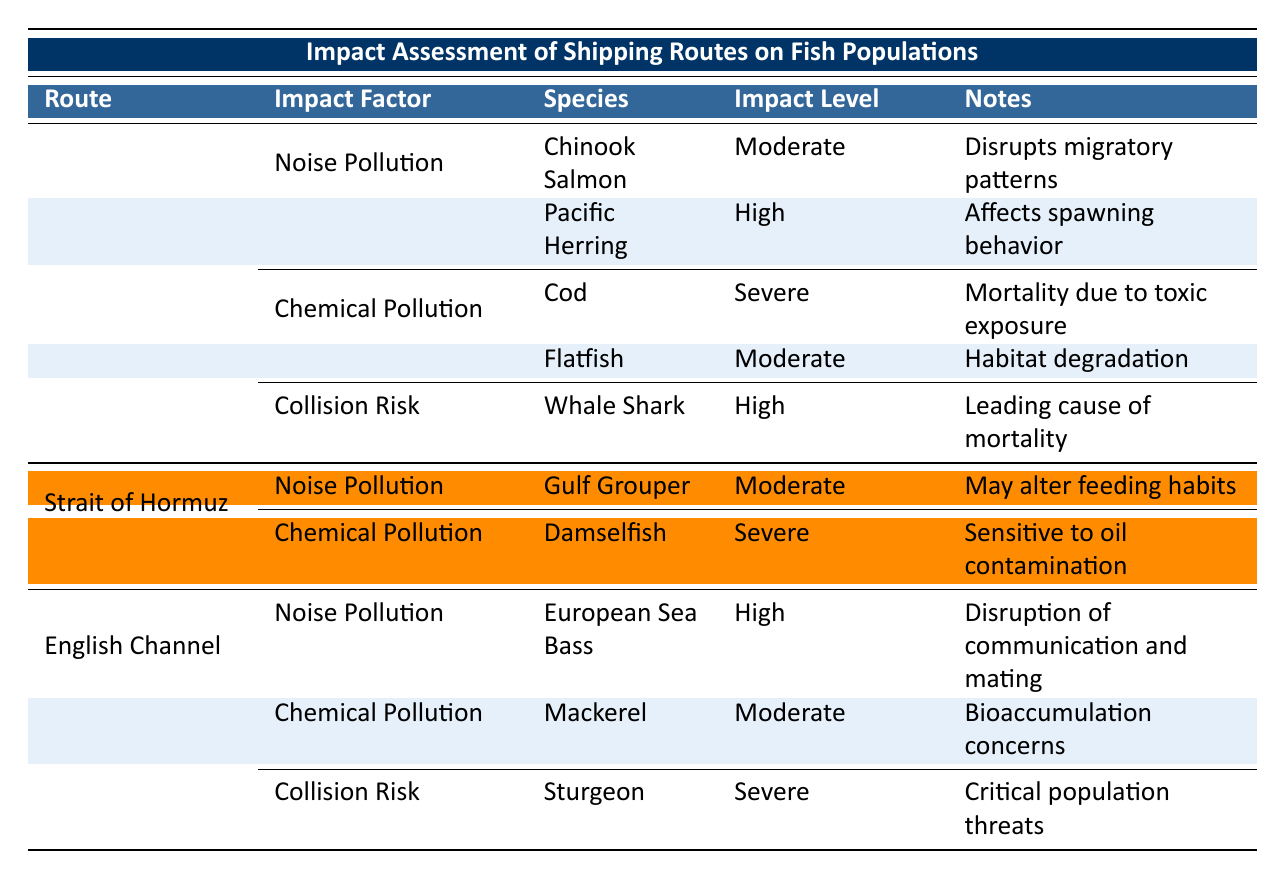What are the impact factors listed for the Bering Sea Route? The table lists Noise Pollution, Chemical Pollution, and Collision Risk as the impact factors for the Bering Sea Route. This is directly observed from the corresponding rows under the route name.
Answer: Noise Pollution, Chemical Pollution, Collision Risk Which fish species are severely impacted by chemical pollution in the Bering Sea Route? The only species listed under severe impact for chemical pollution in the Bering Sea Route is Cod; this can be identified by filtering for the Bering Sea Route and checking the impact level under Chemical Pollution.
Answer: Cod Is the impact level for Pacific Herring higher than that for Flatfish in the Bering Sea Route? Yes, the impact level for Pacific Herring is high while for Flatfish it is moderate. This comparison can be made by looking at the respective impact levels listed for these species in the Bering Sea Route.
Answer: Yes Which shipping route has a fish species that is severely affected by both noise and chemical pollution? The English Channel has Sturgeon, which is severely impacted by collision risk, but none in the table is indicated to be severely affected by both noise and chemical pollution. Therefore, the answer is that no such route exists.
Answer: No What is the total number of species impacted due to noise pollution across all routes? Counting the species affected by noise pollution: Bering Sea Route has 2, Strait of Hormuz has 1, and English Channel has 1, resulting in a total of 4 species. The total is calculated from summing these counts.
Answer: 4 Which shipping route has the highest number of impact factors, and how many are there? The Bering Sea Route has the highest number of impact factors with 3. This can be verified by counting the unique impact factors listed under that route in the table.
Answer: Bering Sea Route, 3 Is it true that the Gulf Grouper is impacted due to collision risk? No, the Gulf Grouper is only indicated to be impacted by noise pollution, and there is no mention of collision risk affecting it within the table.
Answer: No Which fish species experience high impact levels due to noise pollution across all shipping routes? The fish species experiencing high impact levels due to noise pollution include Pacific Herring from the Bering Sea Route, Gulf Grouper from the Strait of Hormuz, and European Sea Bass from the English Channel. Verification involves checking each route for high impact under noise pollution.
Answer: Pacific Herring, Gulf Grouper, European Sea Bass 